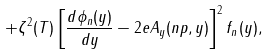Convert formula to latex. <formula><loc_0><loc_0><loc_500><loc_500>+ \zeta ^ { 2 } ( T ) \left [ \frac { d \phi _ { n } ( y ) } { d y } - 2 e A _ { y } ( n p , y ) \right ] ^ { 2 } f _ { n } ( y ) ,</formula> 